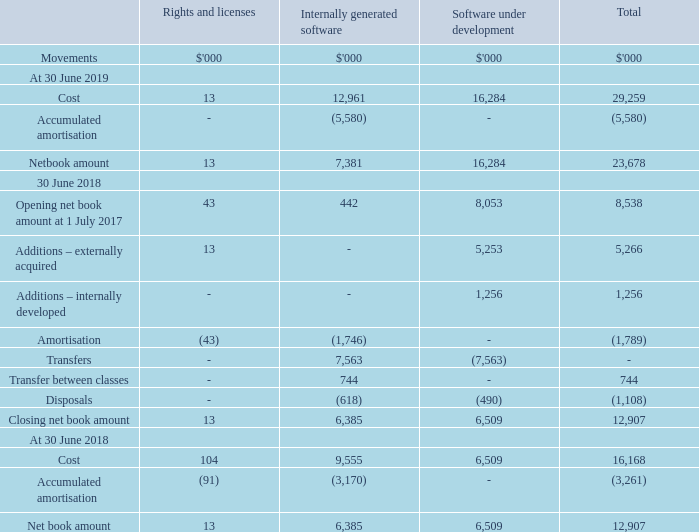11 Intangible assets (continued)
(a) Intangible assets
RIGHTS AND LICENCES
Certain licences that NEXTDC possesses have an indefinite useful life and are carried at cost less impairment losses and are subject to impairment review at least annually and whenever there is an indication that it may be impaired.
Other licences that NEXTDC acquires are carried at cost less accumulated amortisation and accumulated impairment losses. Amortisation is recognised on a straight-line basis over the estimated useful life. The estimated useful life and amortisation method are reviewed at the end of each annual reporting period.
INTERNALLY GENERATED SOFTWARE
Internally developed software is capitalised at cost less accumulated amortisation. Amortisation is calculated using the straight-line basis over the asset’s useful economic life which is generally two to three years. Their useful lives and potential impairment are reviewed at the end of each financial year.
SOFTWARE UNDER DEVELOPMENT
Costs incurred in developing products or systems and costs incurred in acquiring software and licenses that will contribute to future period financial benefits through revenue generation and/or cost reduction are capitalised to software and systems. Costs capitalised include external direct costs of materials and services and employee costs.
Assets in the course of construction include only those costs directly attributable to the development phase and are only recognised following completion of technical feasibility and where the Group has an intention and ability to use the asset.
How was internally developed software capitalised? At cost less accumulated amortisation. How much was the closing net book amount for software under development in 2019?
Answer scale should be: thousand. 16,284. What was the total cost for 2019?
Answer scale should be: thousand. 29,259. What was the percentage change in cost of software under development between 2018 and 2019?
Answer scale should be: percent. (16,284 - 6,509) / 6,509 
Answer: 150.18. Which year have greater total accumulated amortisation?  2019: (5,580) vs 2018: (3,261)
Answer: 2019. What was the difference between total opening and closing net book account in 2018?
Answer scale should be: thousand. 12,907 - 8,538 
Answer: 4369. 